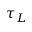<formula> <loc_0><loc_0><loc_500><loc_500>\tau _ { L }</formula> 